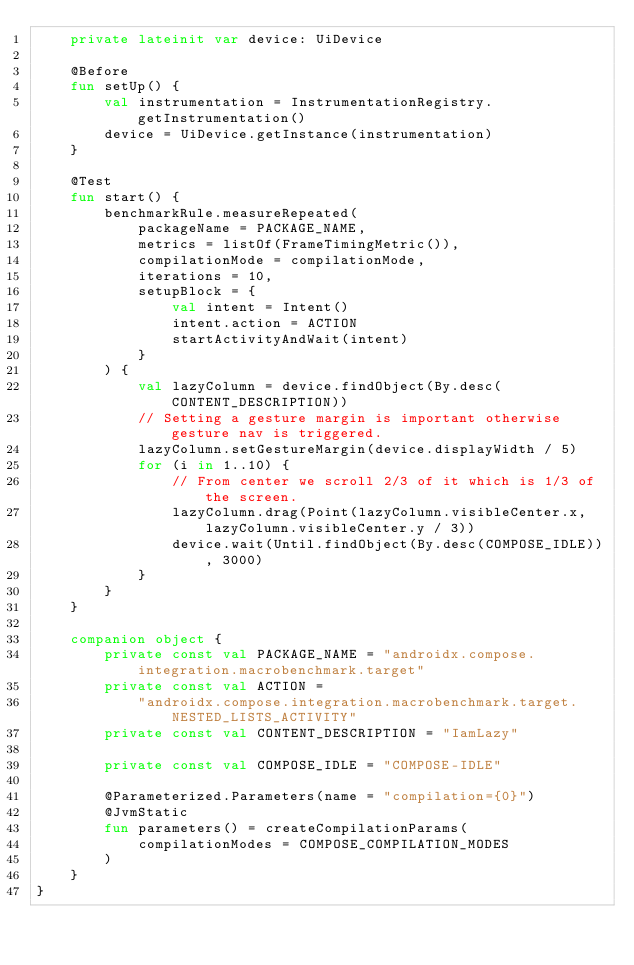Convert code to text. <code><loc_0><loc_0><loc_500><loc_500><_Kotlin_>    private lateinit var device: UiDevice

    @Before
    fun setUp() {
        val instrumentation = InstrumentationRegistry.getInstrumentation()
        device = UiDevice.getInstance(instrumentation)
    }

    @Test
    fun start() {
        benchmarkRule.measureRepeated(
            packageName = PACKAGE_NAME,
            metrics = listOf(FrameTimingMetric()),
            compilationMode = compilationMode,
            iterations = 10,
            setupBlock = {
                val intent = Intent()
                intent.action = ACTION
                startActivityAndWait(intent)
            }
        ) {
            val lazyColumn = device.findObject(By.desc(CONTENT_DESCRIPTION))
            // Setting a gesture margin is important otherwise gesture nav is triggered.
            lazyColumn.setGestureMargin(device.displayWidth / 5)
            for (i in 1..10) {
                // From center we scroll 2/3 of it which is 1/3 of the screen.
                lazyColumn.drag(Point(lazyColumn.visibleCenter.x, lazyColumn.visibleCenter.y / 3))
                device.wait(Until.findObject(By.desc(COMPOSE_IDLE)), 3000)
            }
        }
    }

    companion object {
        private const val PACKAGE_NAME = "androidx.compose.integration.macrobenchmark.target"
        private const val ACTION =
            "androidx.compose.integration.macrobenchmark.target.NESTED_LISTS_ACTIVITY"
        private const val CONTENT_DESCRIPTION = "IamLazy"

        private const val COMPOSE_IDLE = "COMPOSE-IDLE"

        @Parameterized.Parameters(name = "compilation={0}")
        @JvmStatic
        fun parameters() = createCompilationParams(
            compilationModes = COMPOSE_COMPILATION_MODES
        )
    }
}
</code> 